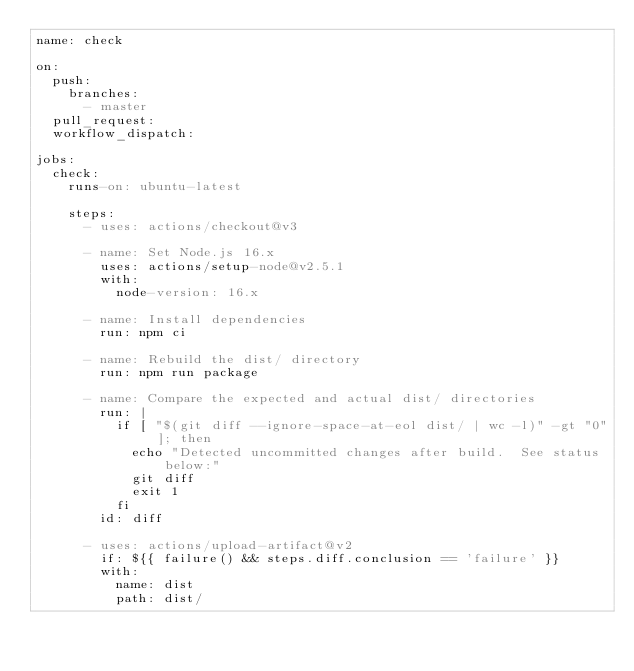<code> <loc_0><loc_0><loc_500><loc_500><_YAML_>name: check

on:
  push:
    branches:
      - master
  pull_request:
  workflow_dispatch:

jobs:
  check:
    runs-on: ubuntu-latest

    steps:
      - uses: actions/checkout@v3

      - name: Set Node.js 16.x
        uses: actions/setup-node@v2.5.1
        with:
          node-version: 16.x

      - name: Install dependencies
        run: npm ci

      - name: Rebuild the dist/ directory
        run: npm run package

      - name: Compare the expected and actual dist/ directories
        run: |
          if [ "$(git diff --ignore-space-at-eol dist/ | wc -l)" -gt "0" ]; then
            echo "Detected uncommitted changes after build.  See status below:"
            git diff
            exit 1
          fi
        id: diff

      - uses: actions/upload-artifact@v2
        if: ${{ failure() && steps.diff.conclusion == 'failure' }}
        with:
          name: dist
          path: dist/</code> 